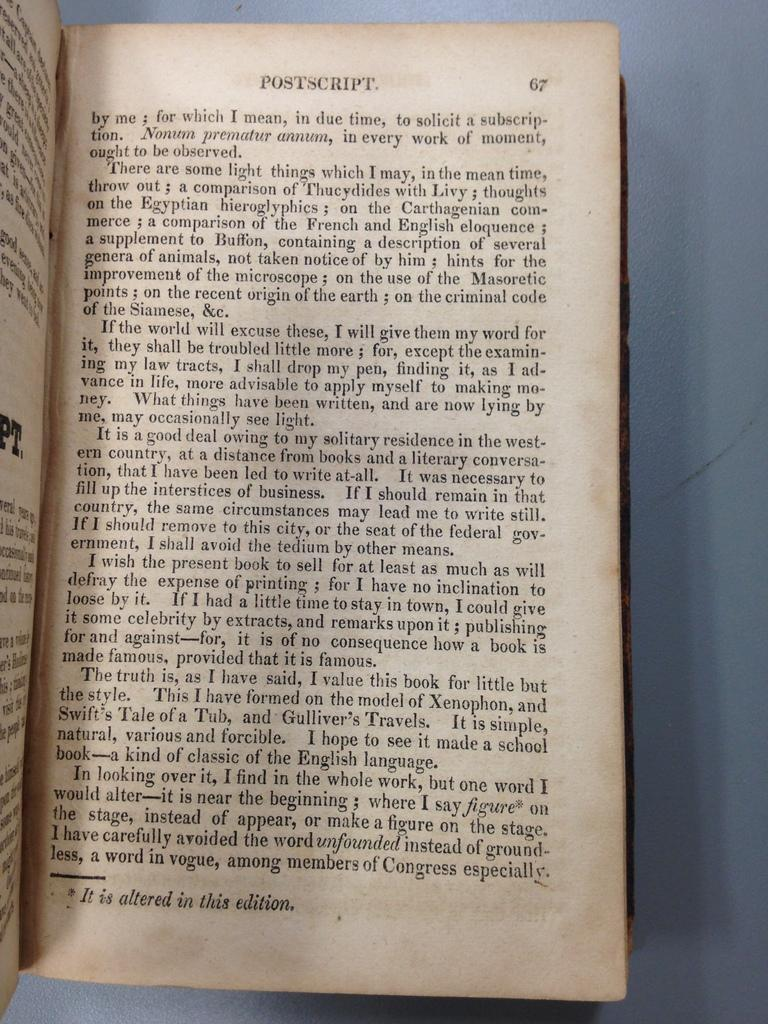<image>
Render a clear and concise summary of the photo. A book with small print starts a chapter called Postscript on page 67 